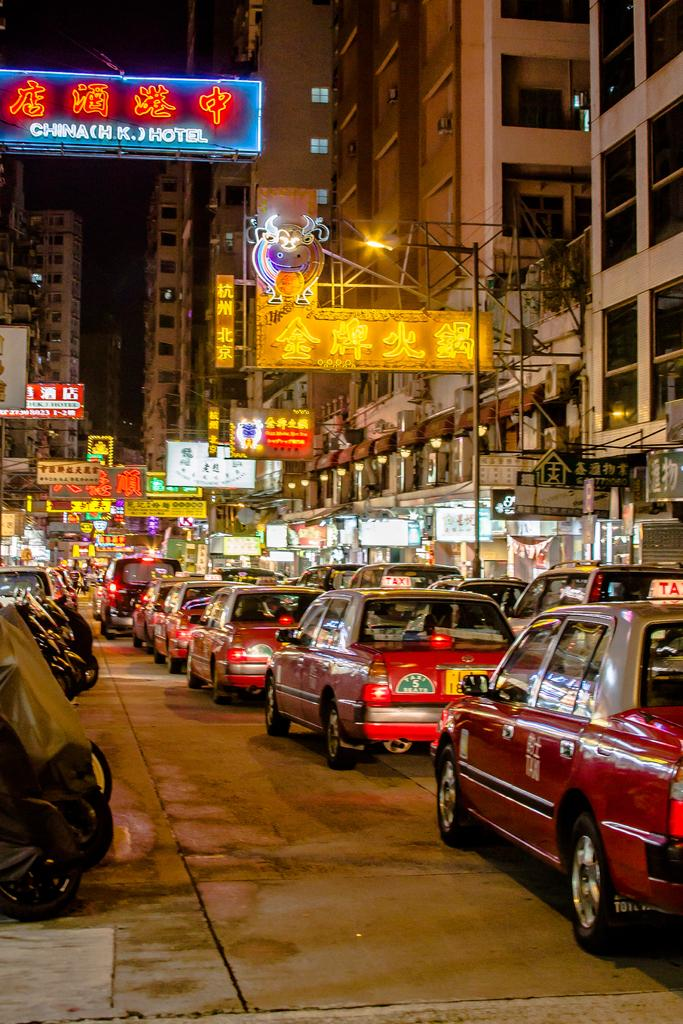<image>
Relay a brief, clear account of the picture shown. A long line of taxis are bumper to bumper on a street adorned with neon business signs, such as hotels. 